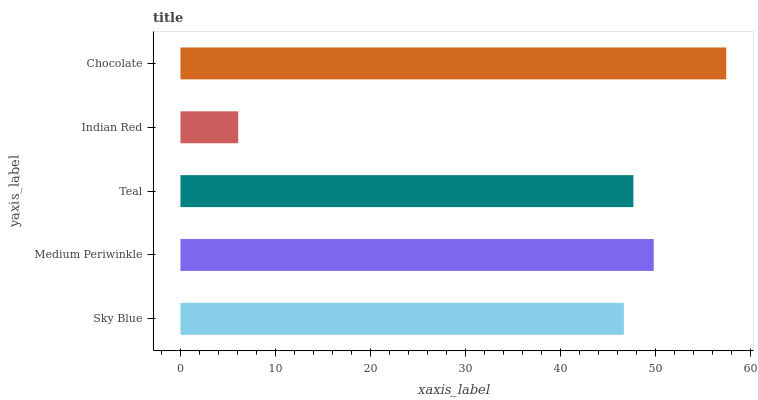Is Indian Red the minimum?
Answer yes or no. Yes. Is Chocolate the maximum?
Answer yes or no. Yes. Is Medium Periwinkle the minimum?
Answer yes or no. No. Is Medium Periwinkle the maximum?
Answer yes or no. No. Is Medium Periwinkle greater than Sky Blue?
Answer yes or no. Yes. Is Sky Blue less than Medium Periwinkle?
Answer yes or no. Yes. Is Sky Blue greater than Medium Periwinkle?
Answer yes or no. No. Is Medium Periwinkle less than Sky Blue?
Answer yes or no. No. Is Teal the high median?
Answer yes or no. Yes. Is Teal the low median?
Answer yes or no. Yes. Is Medium Periwinkle the high median?
Answer yes or no. No. Is Sky Blue the low median?
Answer yes or no. No. 